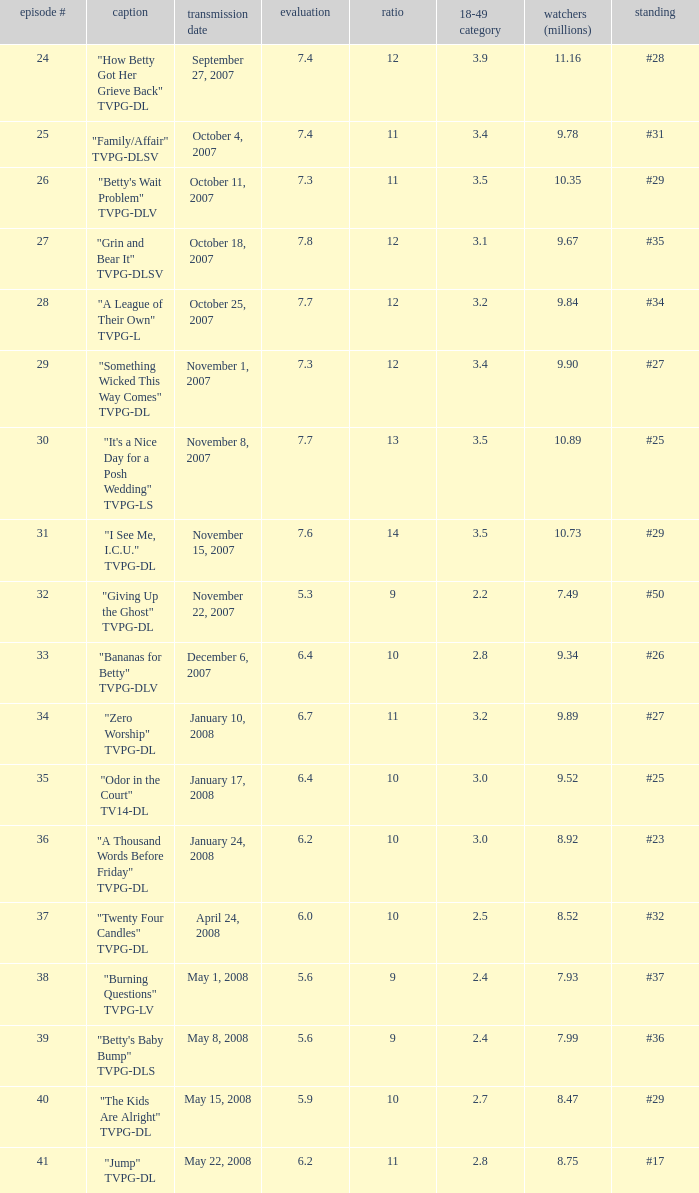Could you help me parse every detail presented in this table? {'header': ['episode #', 'caption', 'transmission date', 'evaluation', 'ratio', '18-49 category', 'watchers (millions)', 'standing'], 'rows': [['24', '"How Betty Got Her Grieve Back" TVPG-DL', 'September 27, 2007', '7.4', '12', '3.9', '11.16', '#28'], ['25', '"Family/Affair" TVPG-DLSV', 'October 4, 2007', '7.4', '11', '3.4', '9.78', '#31'], ['26', '"Betty\'s Wait Problem" TVPG-DLV', 'October 11, 2007', '7.3', '11', '3.5', '10.35', '#29'], ['27', '"Grin and Bear It" TVPG-DLSV', 'October 18, 2007', '7.8', '12', '3.1', '9.67', '#35'], ['28', '"A League of Their Own" TVPG-L', 'October 25, 2007', '7.7', '12', '3.2', '9.84', '#34'], ['29', '"Something Wicked This Way Comes" TVPG-DL', 'November 1, 2007', '7.3', '12', '3.4', '9.90', '#27'], ['30', '"It\'s a Nice Day for a Posh Wedding" TVPG-LS', 'November 8, 2007', '7.7', '13', '3.5', '10.89', '#25'], ['31', '"I See Me, I.C.U." TVPG-DL', 'November 15, 2007', '7.6', '14', '3.5', '10.73', '#29'], ['32', '"Giving Up the Ghost" TVPG-DL', 'November 22, 2007', '5.3', '9', '2.2', '7.49', '#50'], ['33', '"Bananas for Betty" TVPG-DLV', 'December 6, 2007', '6.4', '10', '2.8', '9.34', '#26'], ['34', '"Zero Worship" TVPG-DL', 'January 10, 2008', '6.7', '11', '3.2', '9.89', '#27'], ['35', '"Odor in the Court" TV14-DL', 'January 17, 2008', '6.4', '10', '3.0', '9.52', '#25'], ['36', '"A Thousand Words Before Friday" TVPG-DL', 'January 24, 2008', '6.2', '10', '3.0', '8.92', '#23'], ['37', '"Twenty Four Candles" TVPG-DL', 'April 24, 2008', '6.0', '10', '2.5', '8.52', '#32'], ['38', '"Burning Questions" TVPG-LV', 'May 1, 2008', '5.6', '9', '2.4', '7.93', '#37'], ['39', '"Betty\'s Baby Bump" TVPG-DLS', 'May 8, 2008', '5.6', '9', '2.4', '7.99', '#36'], ['40', '"The Kids Are Alright" TVPG-DL', 'May 15, 2008', '5.9', '10', '2.7', '8.47', '#29'], ['41', '"Jump" TVPG-DL', 'May 22, 2008', '6.2', '11', '2.8', '8.75', '#17']]} What is the Airdate of the episode that ranked #29 and had a share greater than 10? May 15, 2008. 